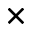Convert formula to latex. <formula><loc_0><loc_0><loc_500><loc_500>\times</formula> 